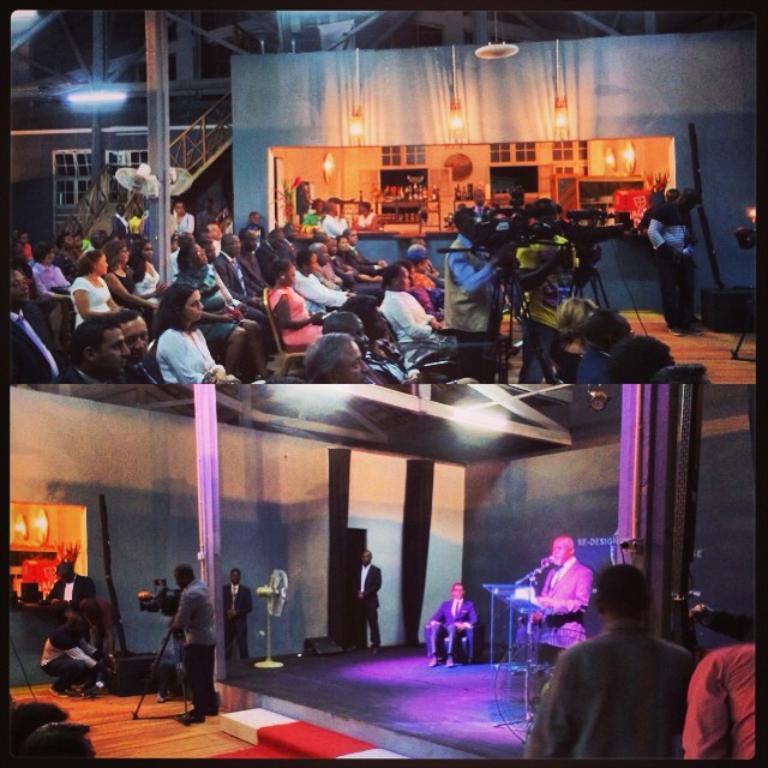Please provide a concise description of this image. This picture is a collage picture. At the top of the image there are group of people sitting on chairs and there is a person standing and holding the camera. At the back there are windows and there are bottles in the cupboard. At the bottom of the image there is a person standing behind the podium and there is a person sitting and there are group of people standing. At the top there are lights. 